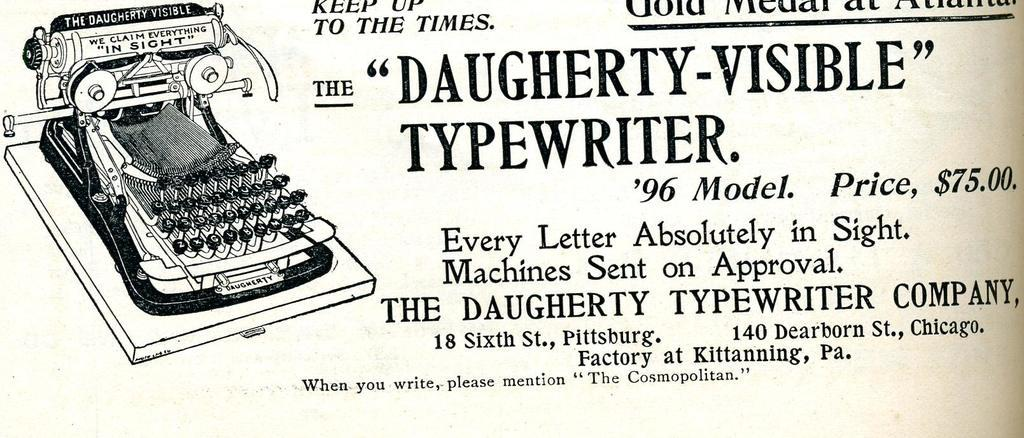What can be seen in the image besides the drawing of a typewriter? There are texts written in the image. What object is depicted in the drawing? The drawing is of a typewriter. What type of substance is being applied to the pet's skin in the image? There is no pet or substance application present in the image. What color is the pet's skin in the image? There is no pet present in the image, so it is not possible to determine the color of its skin. 